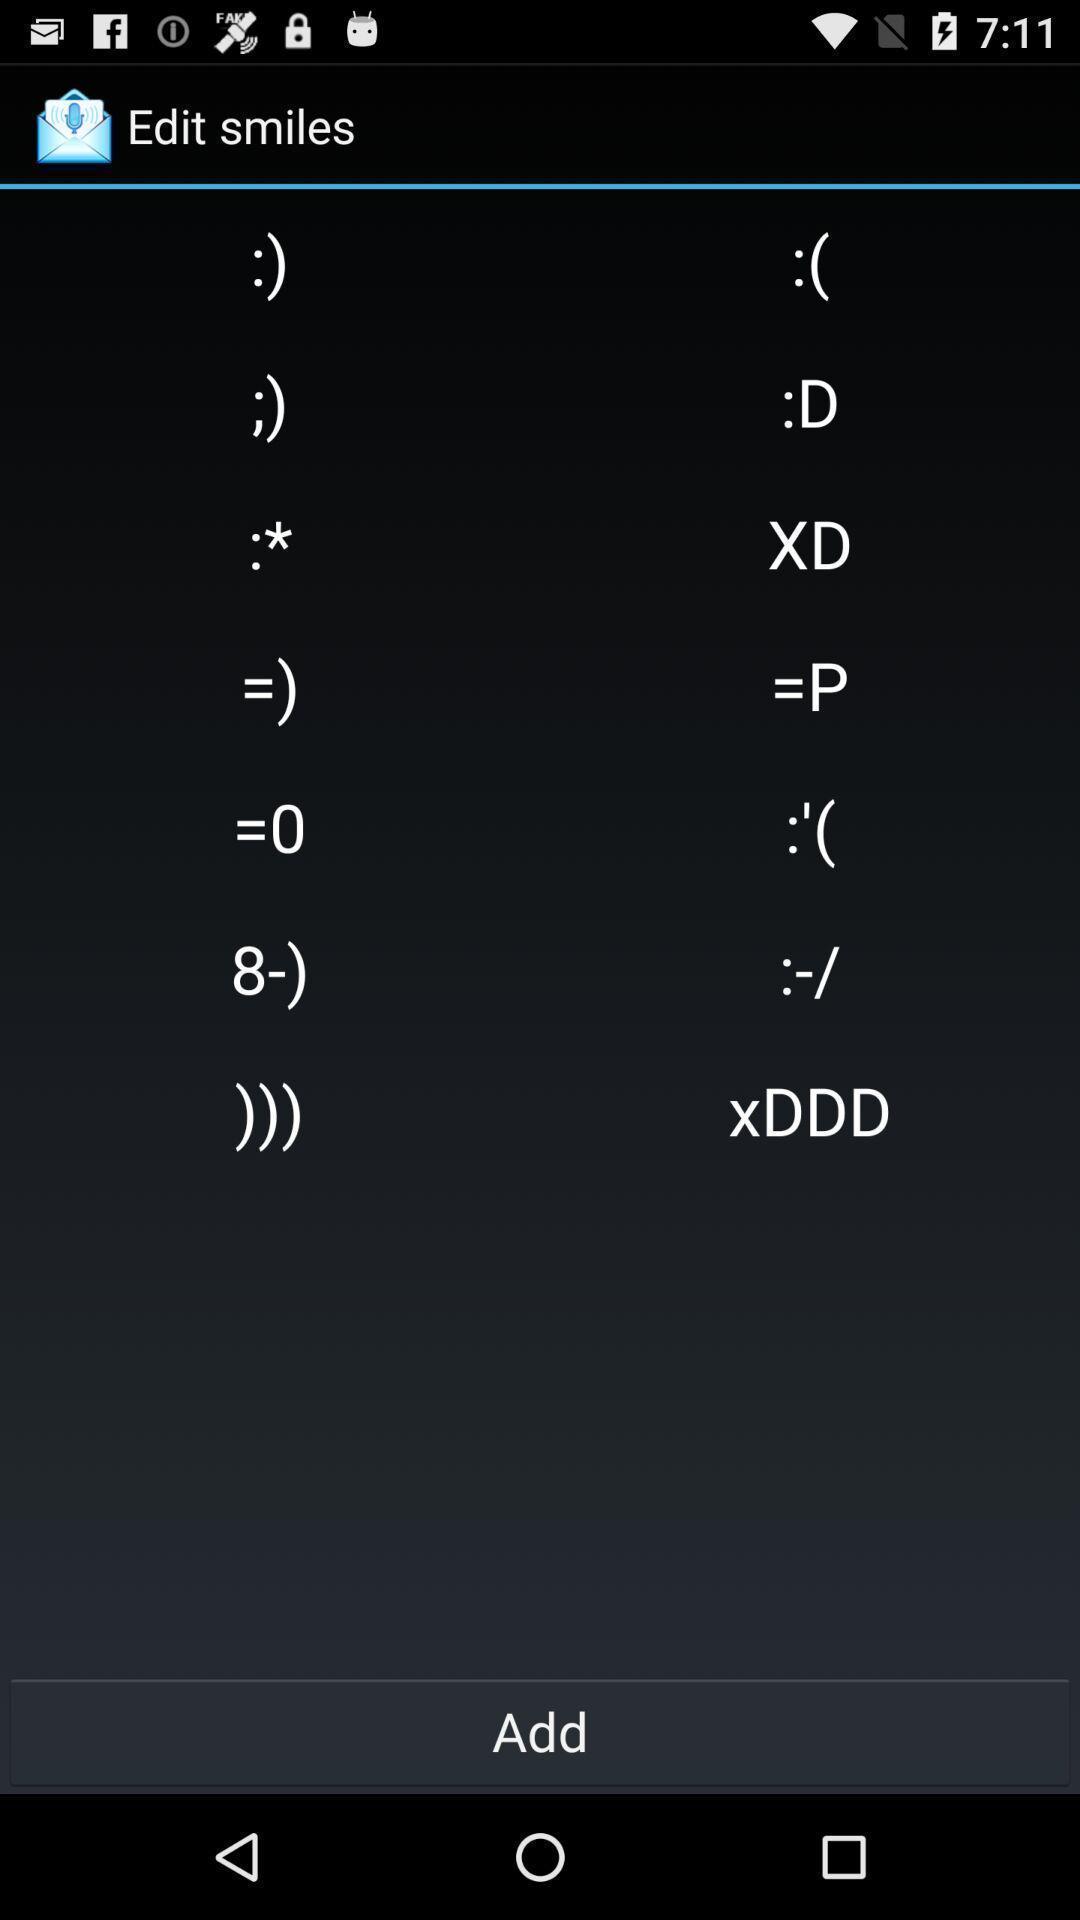Summarize the information in this screenshot. Page displaying the different expressions of the app. 